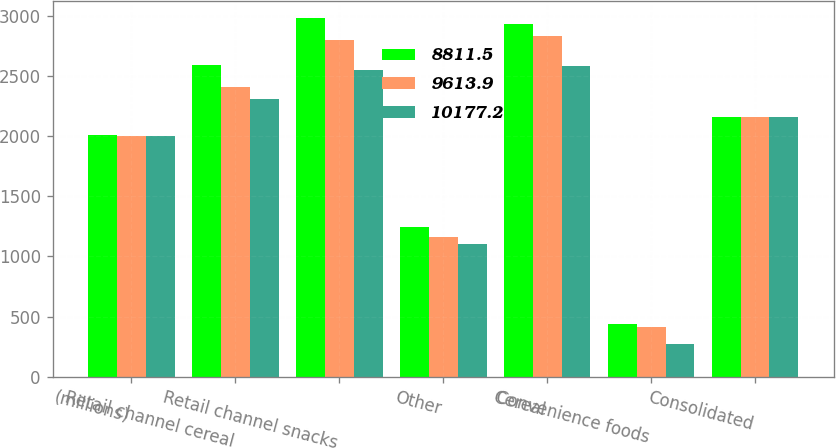Convert chart. <chart><loc_0><loc_0><loc_500><loc_500><stacked_bar_chart><ecel><fcel>(millions)<fcel>Retail channel cereal<fcel>Retail channel snacks<fcel>Other<fcel>Cereal<fcel>Convenience foods<fcel>Consolidated<nl><fcel>8811.5<fcel>2005<fcel>2587.7<fcel>2976.6<fcel>1243.5<fcel>2932.8<fcel>436.6<fcel>2154.85<nl><fcel>9613.9<fcel>2004<fcel>2404.5<fcel>2801.4<fcel>1163.4<fcel>2829.2<fcel>415.4<fcel>2154.85<nl><fcel>10177.2<fcel>2003<fcel>2304.7<fcel>2547.6<fcel>1102<fcel>2583.5<fcel>273.7<fcel>2154.85<nl></chart> 